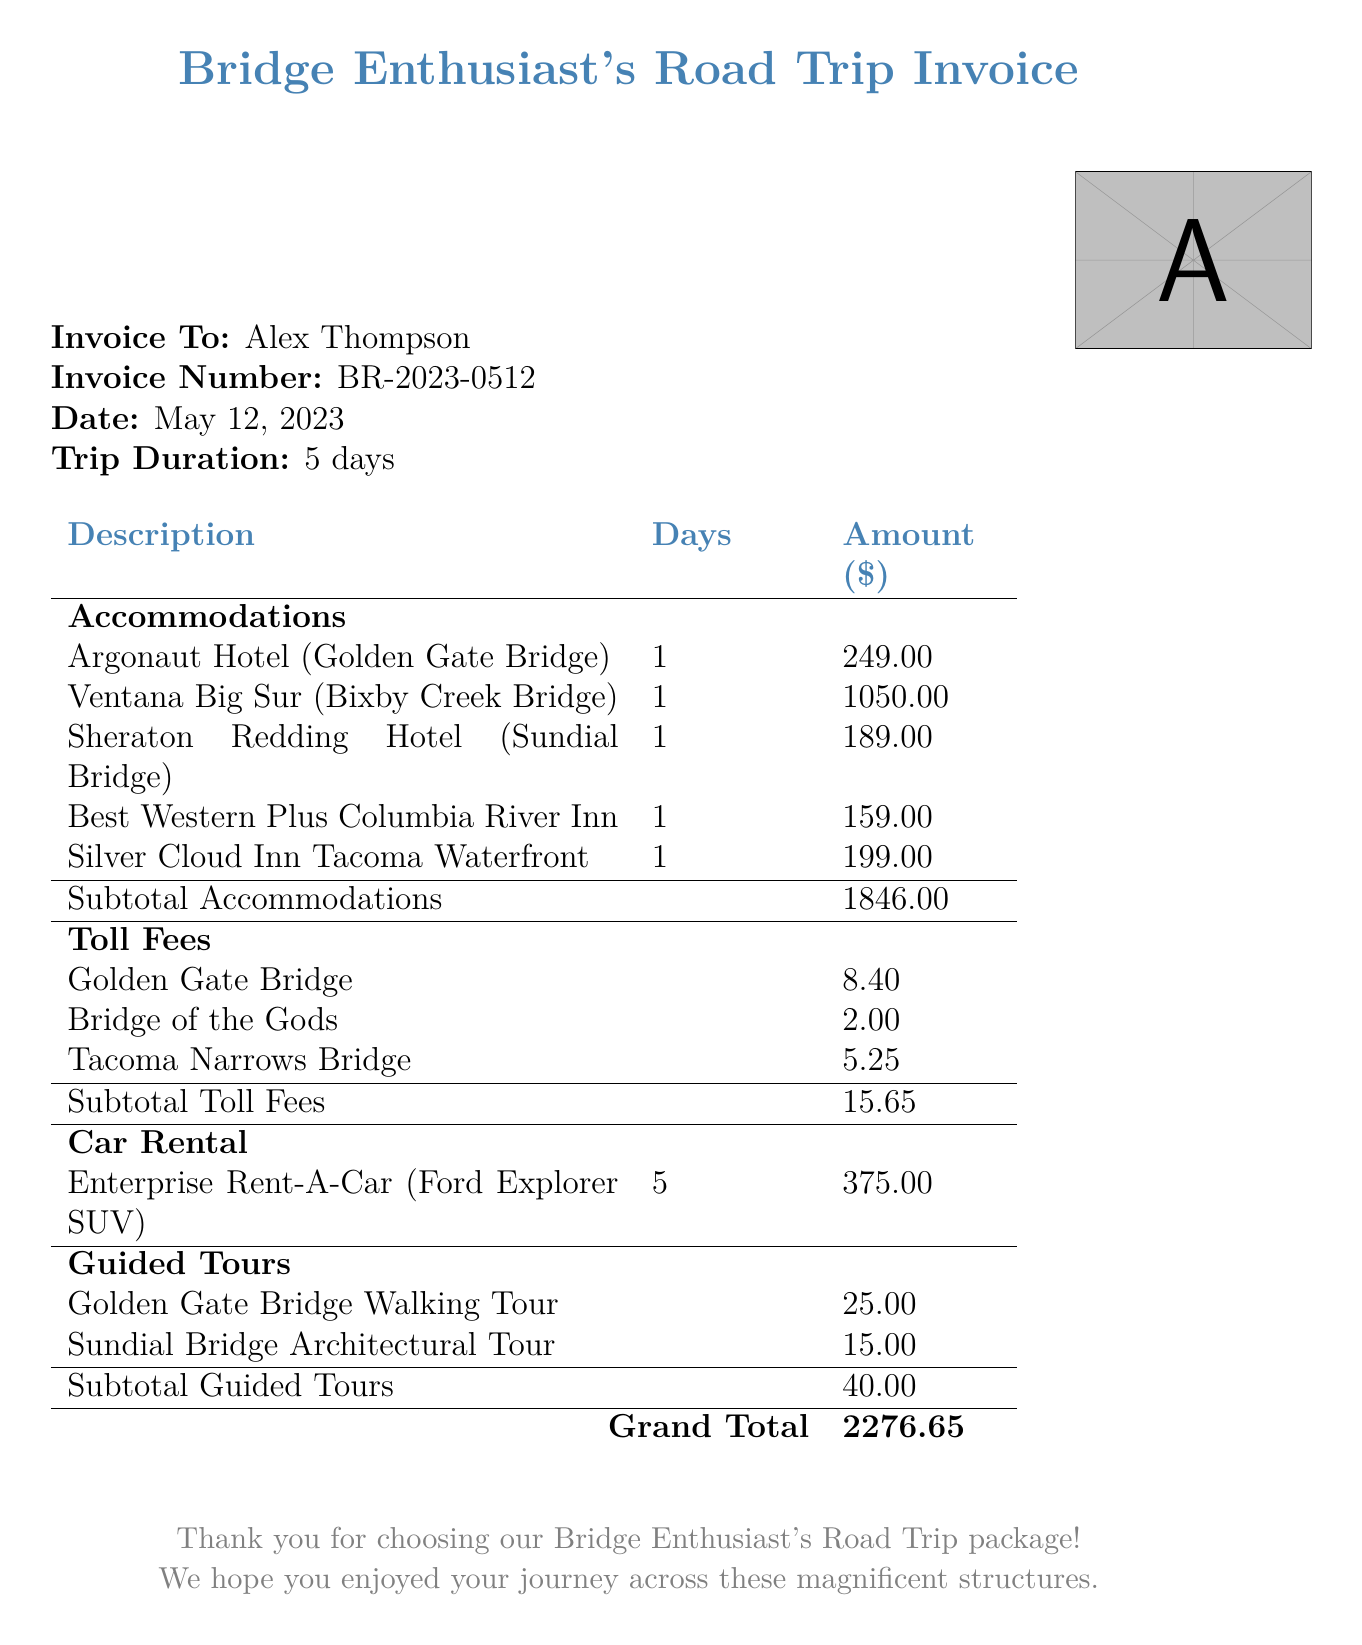What is the total amount due for the trip? The total amount due is listed at the end of the document as the Grand Total.
Answer: 2276.65 Who is the invoice addressed to? The 'Invoice To' section identifies the recipient of the invoice.
Answer: Alex Thompson How many days did the trip last? The document specifies the duration of the trip in the 'Trip Duration' field.
Answer: 5 days What is the accommodation expense for the Ventana Big Sur? The specific cost for Ventana Big Sur can be found in the accommodations section.
Answer: 1050.00 Which bridge had the highest toll fee? A comparison of the toll fees listed in the toll fees section reveals which is the highest.
Answer: Tacoma Narrows Bridge What was the car rental company used? The car rental company is specified in the 'Car Rental' section of the document.
Answer: Enterprise Rent-A-Car What is the subtotal for accommodations? The subtotal for accommodations is calculated and shown in the accommodations section just before the toll fees.
Answer: 1846.00 How much did the guided tour of the Golden Gate Bridge cost? The expense for the guided tour is specified directly in the guided tours section.
Answer: 25.00 What type of vehicle was rented? The type of vehicle rented is mentioned in the car rental section of the invoice.
Answer: Ford Explorer SUV 